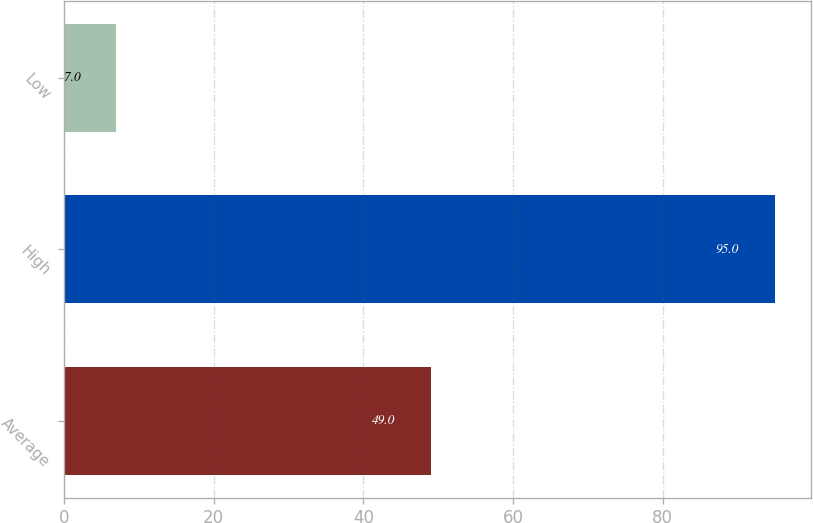Convert chart to OTSL. <chart><loc_0><loc_0><loc_500><loc_500><bar_chart><fcel>Average<fcel>High<fcel>Low<nl><fcel>49<fcel>95<fcel>7<nl></chart> 